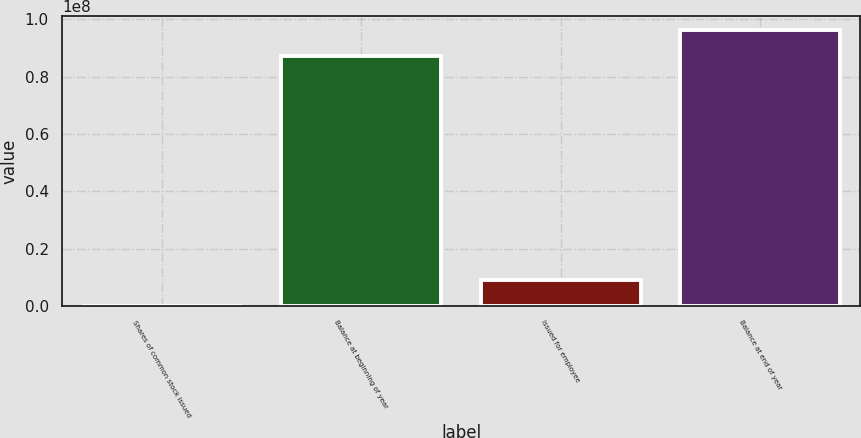Convert chart. <chart><loc_0><loc_0><loc_500><loc_500><bar_chart><fcel>Shares of common stock issued<fcel>Balance at beginning of year<fcel>Issued for employee<fcel>Balance at end of year<nl><fcel>2005<fcel>8.72575e+07<fcel>8.95842e+06<fcel>9.62139e+07<nl></chart> 